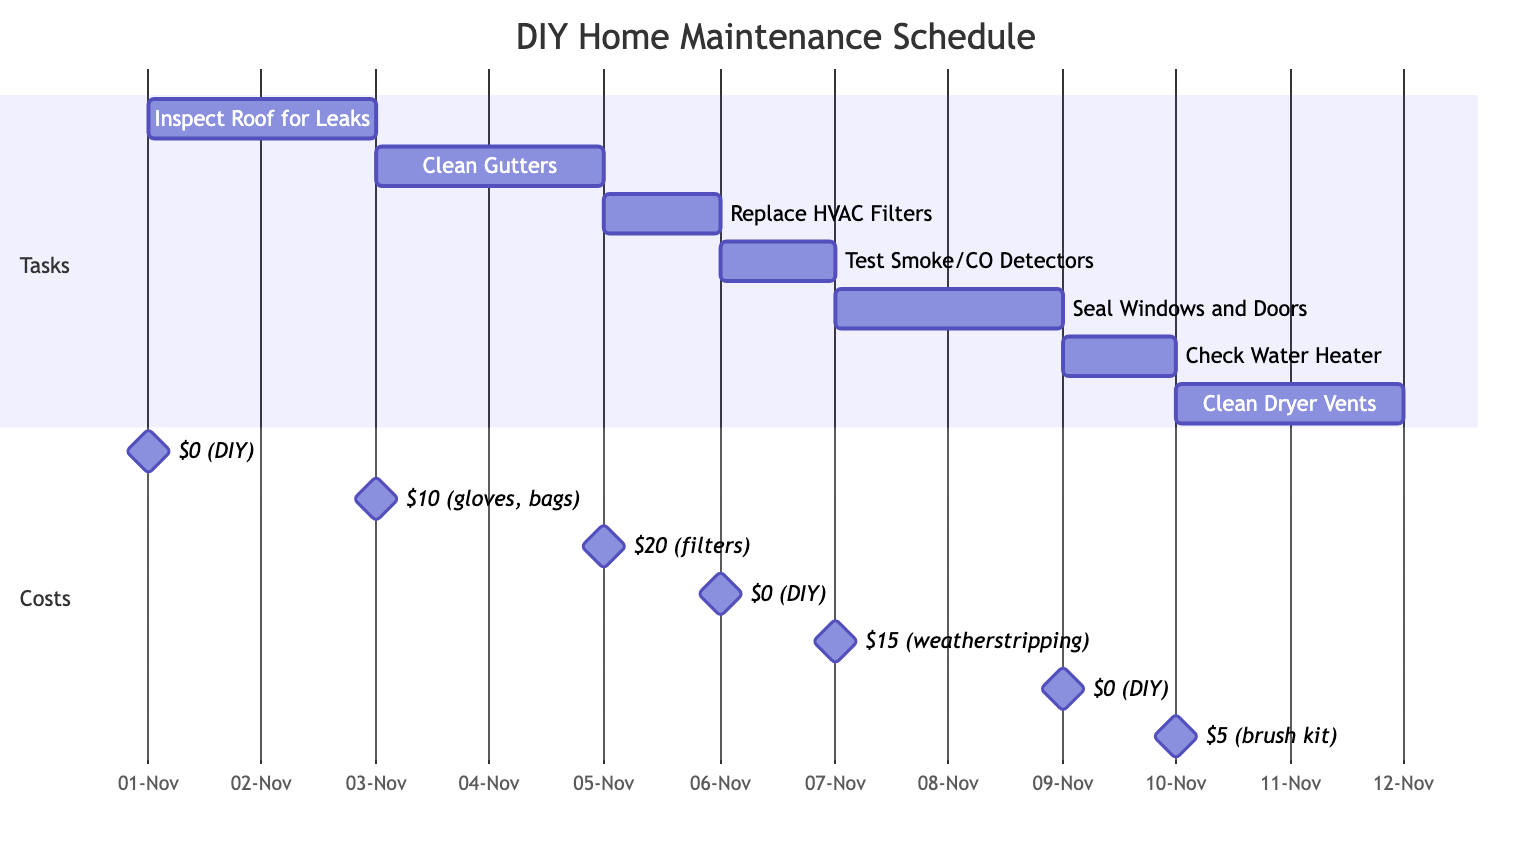What is the duration of the "Replace HVAC Filters" task? The "Replace HVAC Filters" task is listed in the diagram, showing that it spans 1 day from November 5, 2023, to November 5, 2023.
Answer: 1 day How much does "Clean Gutters" cost? From the costs section, "Clean Gutters" is associated with a cost of $10 for gloves and trash bags.
Answer: $10 (gloves and trash bags) How many tasks are scheduled after November 7, 2023? There are two tasks scheduled after November 7, which are "Check Water Heater" on November 9 and "Clean Dryer Vents" on November 10.
Answer: 2 tasks What task occurs immediately after "Inspect Roof for Leaks"? The task that follows "Inspect Roof for Leaks" is "Clean Gutters," starting on November 3, 2023.
Answer: Clean Gutters Which task requires a $0 cost? The tasks with $0 cost are "Inspect Roof for Leaks," "Test Smoke and Carbon Monoxide Detectors," and "Check and Flush Water Heater."
Answer: Inspect Roof for Leaks Which task has the highest cost? The task with the highest cost is "Replace HVAC Filters," with a total cost of $20 for the filters.
Answer: $20 (filters) What is the total duration of all tasks combined? By adding the durations of all tasks: 2 days (Inspect Roof) + 2 days (Clean Gutters) + 1 day (Replace HVAC Filters) + 1 day (Test Detectors) + 2 days (Seal Windows) + 1 day (Check Water Heater) + 2 days (Clean Vents) = 11 days total.
Answer: 11 days What is the cost of "Clean and Inspect Dryer Vents"? The cost for "Clean and Inspect Dryer Vents" is $5 for the brush kit, which is noted in the costs section.
Answer: $5 (brush kit) 